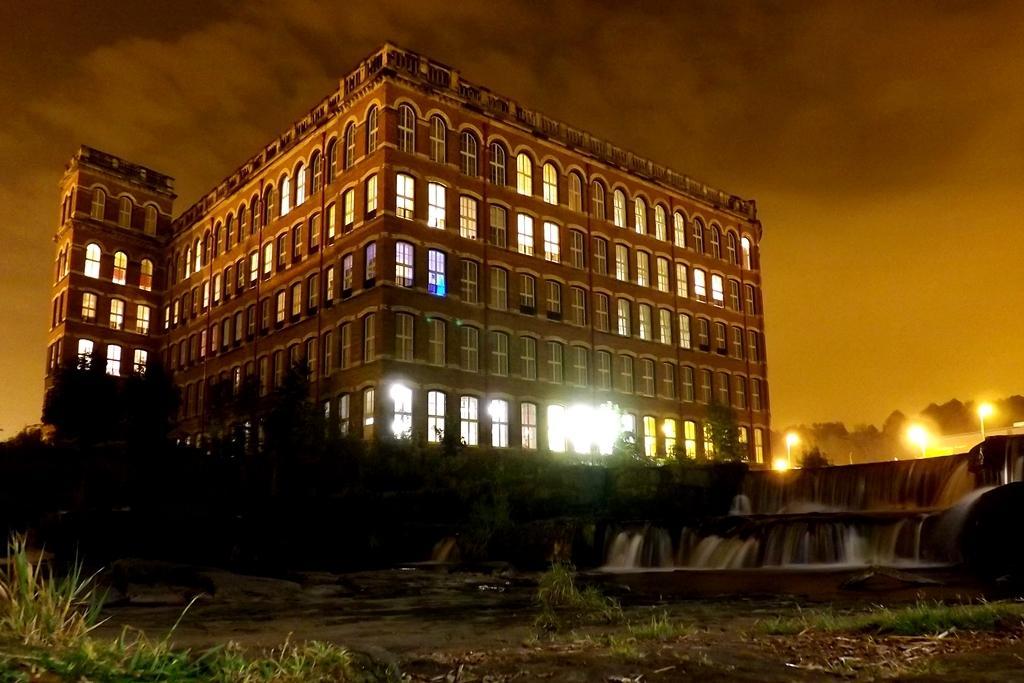Please provide a concise description of this image. This is the picture of a place where we have a building to which there are some windows which has some lights and around there are some trees, plants and some water to the side. 